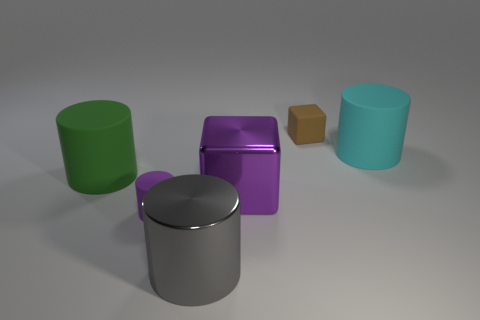Add 2 small purple rubber cylinders. How many objects exist? 8 Subtract all blocks. How many objects are left? 4 Subtract 0 cyan blocks. How many objects are left? 6 Subtract all big purple shiny things. Subtract all large matte objects. How many objects are left? 3 Add 6 brown blocks. How many brown blocks are left? 7 Add 2 tiny cyan cylinders. How many tiny cyan cylinders exist? 2 